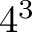<formula> <loc_0><loc_0><loc_500><loc_500>4 ^ { 3 }</formula> 